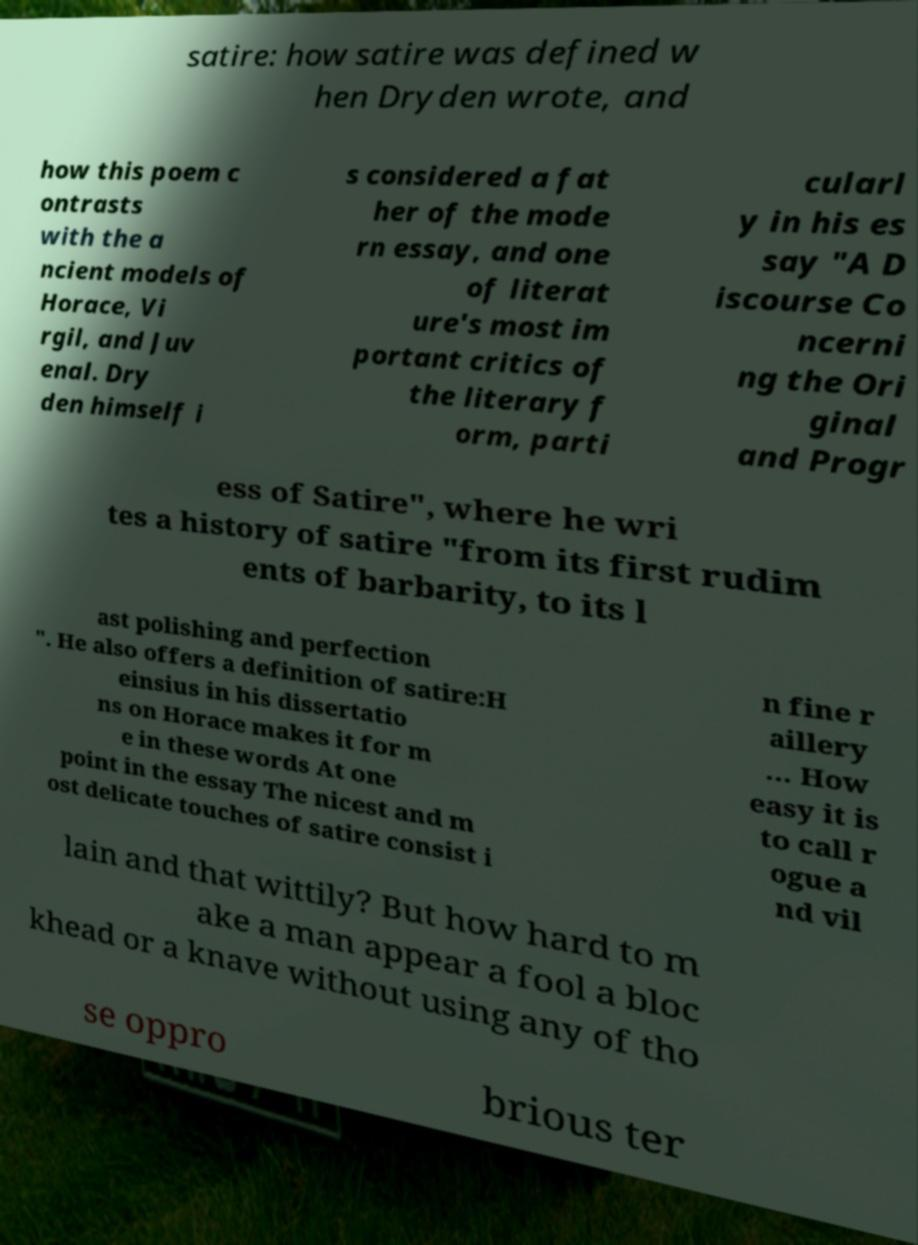Please read and relay the text visible in this image. What does it say? satire: how satire was defined w hen Dryden wrote, and how this poem c ontrasts with the a ncient models of Horace, Vi rgil, and Juv enal. Dry den himself i s considered a fat her of the mode rn essay, and one of literat ure's most im portant critics of the literary f orm, parti cularl y in his es say "A D iscourse Co ncerni ng the Ori ginal and Progr ess of Satire", where he wri tes a history of satire "from its first rudim ents of barbarity, to its l ast polishing and perfection ". He also offers a definition of satire:H einsius in his dissertatio ns on Horace makes it for m e in these words At one point in the essay The nicest and m ost delicate touches of satire consist i n fine r aillery … How easy it is to call r ogue a nd vil lain and that wittily? But how hard to m ake a man appear a fool a bloc khead or a knave without using any of tho se oppro brious ter 